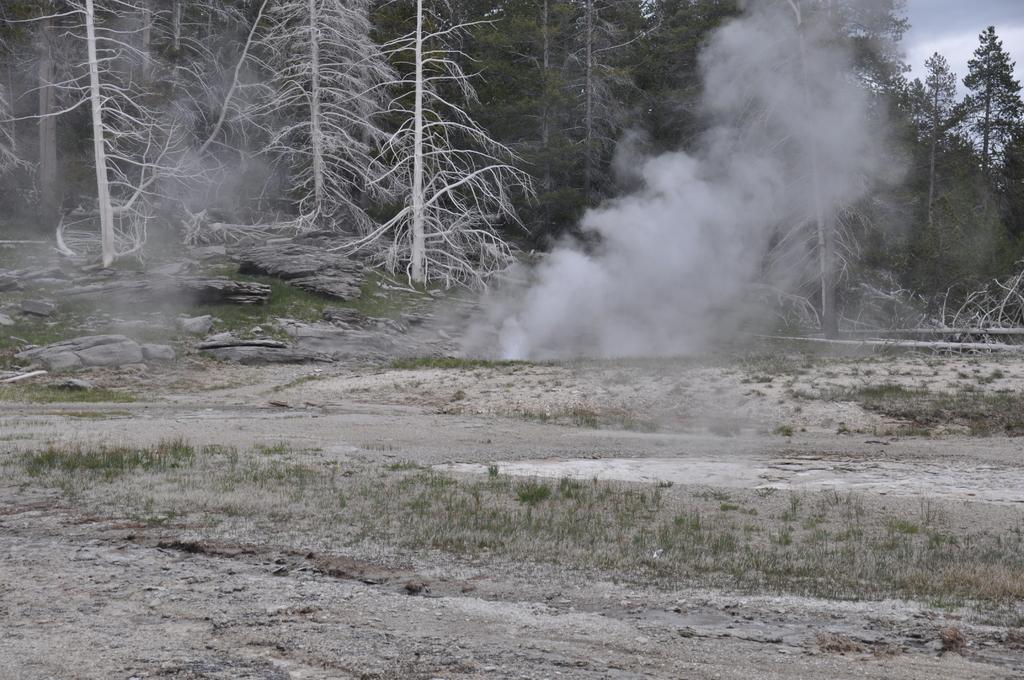Can you describe this image briefly? In this picture we can see a few plants and stones on the path. We can see smoke in the air. There are a few trees in the background. 